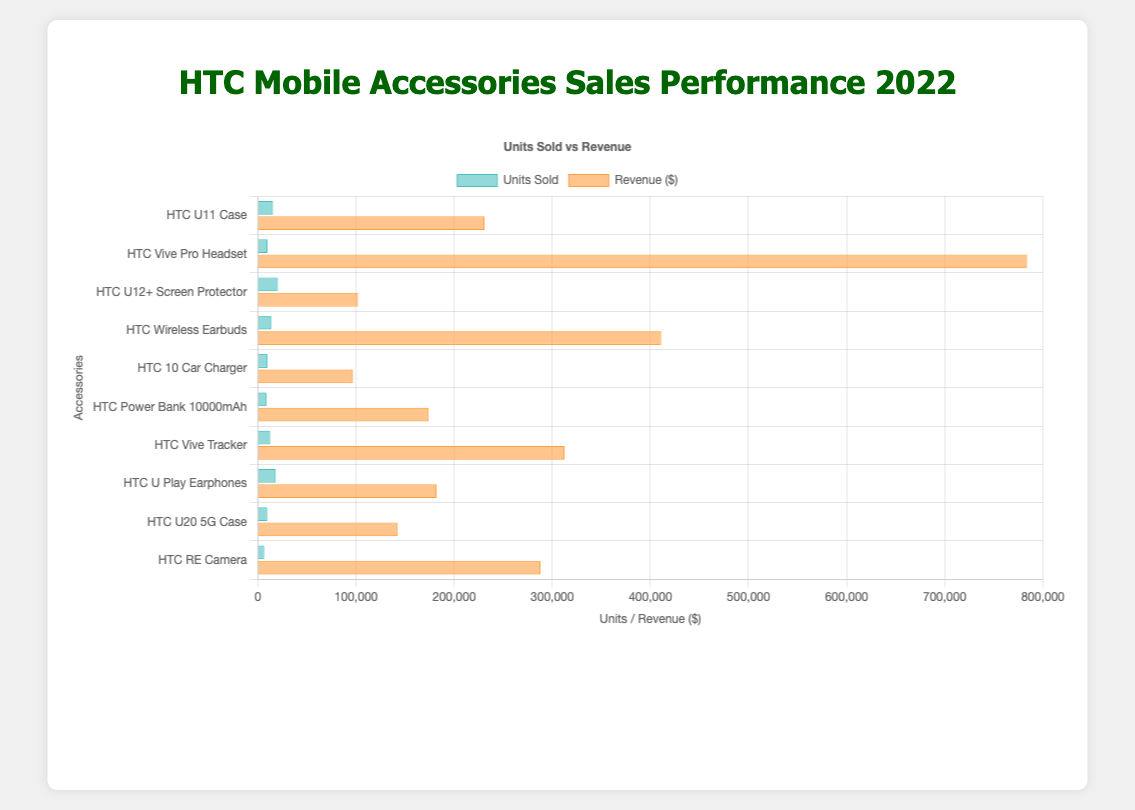Which accessory generated the highest revenue? From the chart, visually identify the bar with the highest value in the 'Revenue ($)' category, which is the "HTC Vive Pro Headset."
Answer: HTC Vive Pro Headset Which accessory had the highest units sold? Refer to the chart's 'Units Sold' category and find the longest bar, which represents the "HTC U12+ Screen Protector."
Answer: HTC U12+ Screen Protector What is the total revenue generated by all accessories combined? Sum the 'Revenue ($)' values of all accessories: 231000 + 784000 + 102000 + 411000 + 97000 + 174000 + 312500 + 182000 + 142500 + 288000 = 2822000.
Answer: 2,822,000 Which accessory had the lowest units sold? Look at the 'Units Sold' section of the chart and find the shortest bar, which represents the "HTC RE Camera."
Answer: HTC RE Camera How does the revenue of "HTC Wireless Earbuds" compare to "HTC U20 5G Case"? Find the bars for 'Revenue ($)' of both accessories and compare their lengths. "HTC Wireless Earbuds" had higher revenue ($411,000) compared to "HTC U20 5G Case" ($142,500).
Answer: HTC Wireless Earbuds > HTC U20 5G Case What is the difference in units sold between "HTC Vive Tracker" and "HTC Wireless Earbuds"? From the 'Units Sold' section, subtract the number of units sold for "HTC Wireless Earbuds" (13,700) from "HTC Vive Tracker" (12,500), which is 13,700 - 12,500 = 1,200.
Answer: 1,200 Calculate the average number of units sold for all accessories. Sum the 'Units Sold' values of all accessories and divide by the number of accessories: (15400 + 9800 + 20400 + 13700 + 9700 + 8700 + 12500 + 18200 + 9500 + 6400) / 10 = 13600.
Answer: 13,600 Is the revenue of "HTC U Play Earphones" greater than the revenue of "HTC Power Bank 10000mAh"? Compare the 'Revenue ($)' bars. "HTC U Play Earphones" had revenue of $182,000, while "HTC Power Bank 10000mAh" had revenue of $174,000.
Answer: Yes Combine the units sold for "HTC 10 Car Charger" and "HTC RE Camera." What is the total? Add the 'Units Sold' values of "HTC 10 Car Charger" (9,700) and "HTC RE Camera" (6,400): 9700 + 6400 = 16,100.
Answer: 16,100 What is the ratio of revenue to units sold for "HTC Vive Pro Headset"? Calculate the ratio by dividing the revenue by units sold for "HTC Vive Pro Headset" (784,000 / 9,800). The ratio is approximately 80.
Answer: 80 